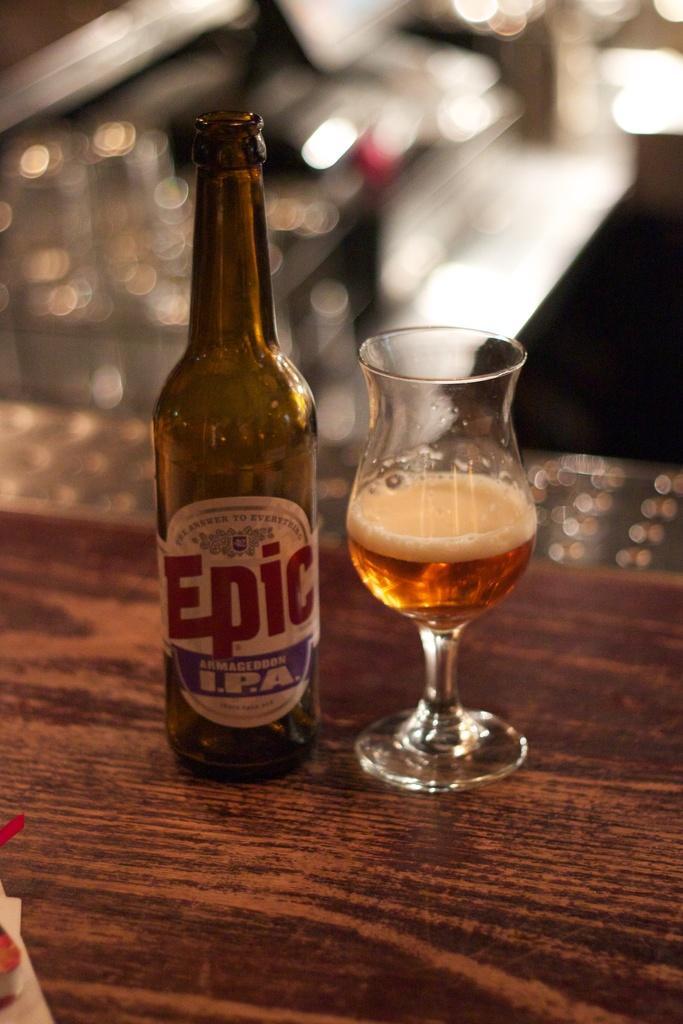Describe this image in one or two sentences. In this picture there is a bottle and a glass beside the bottle on the table. 